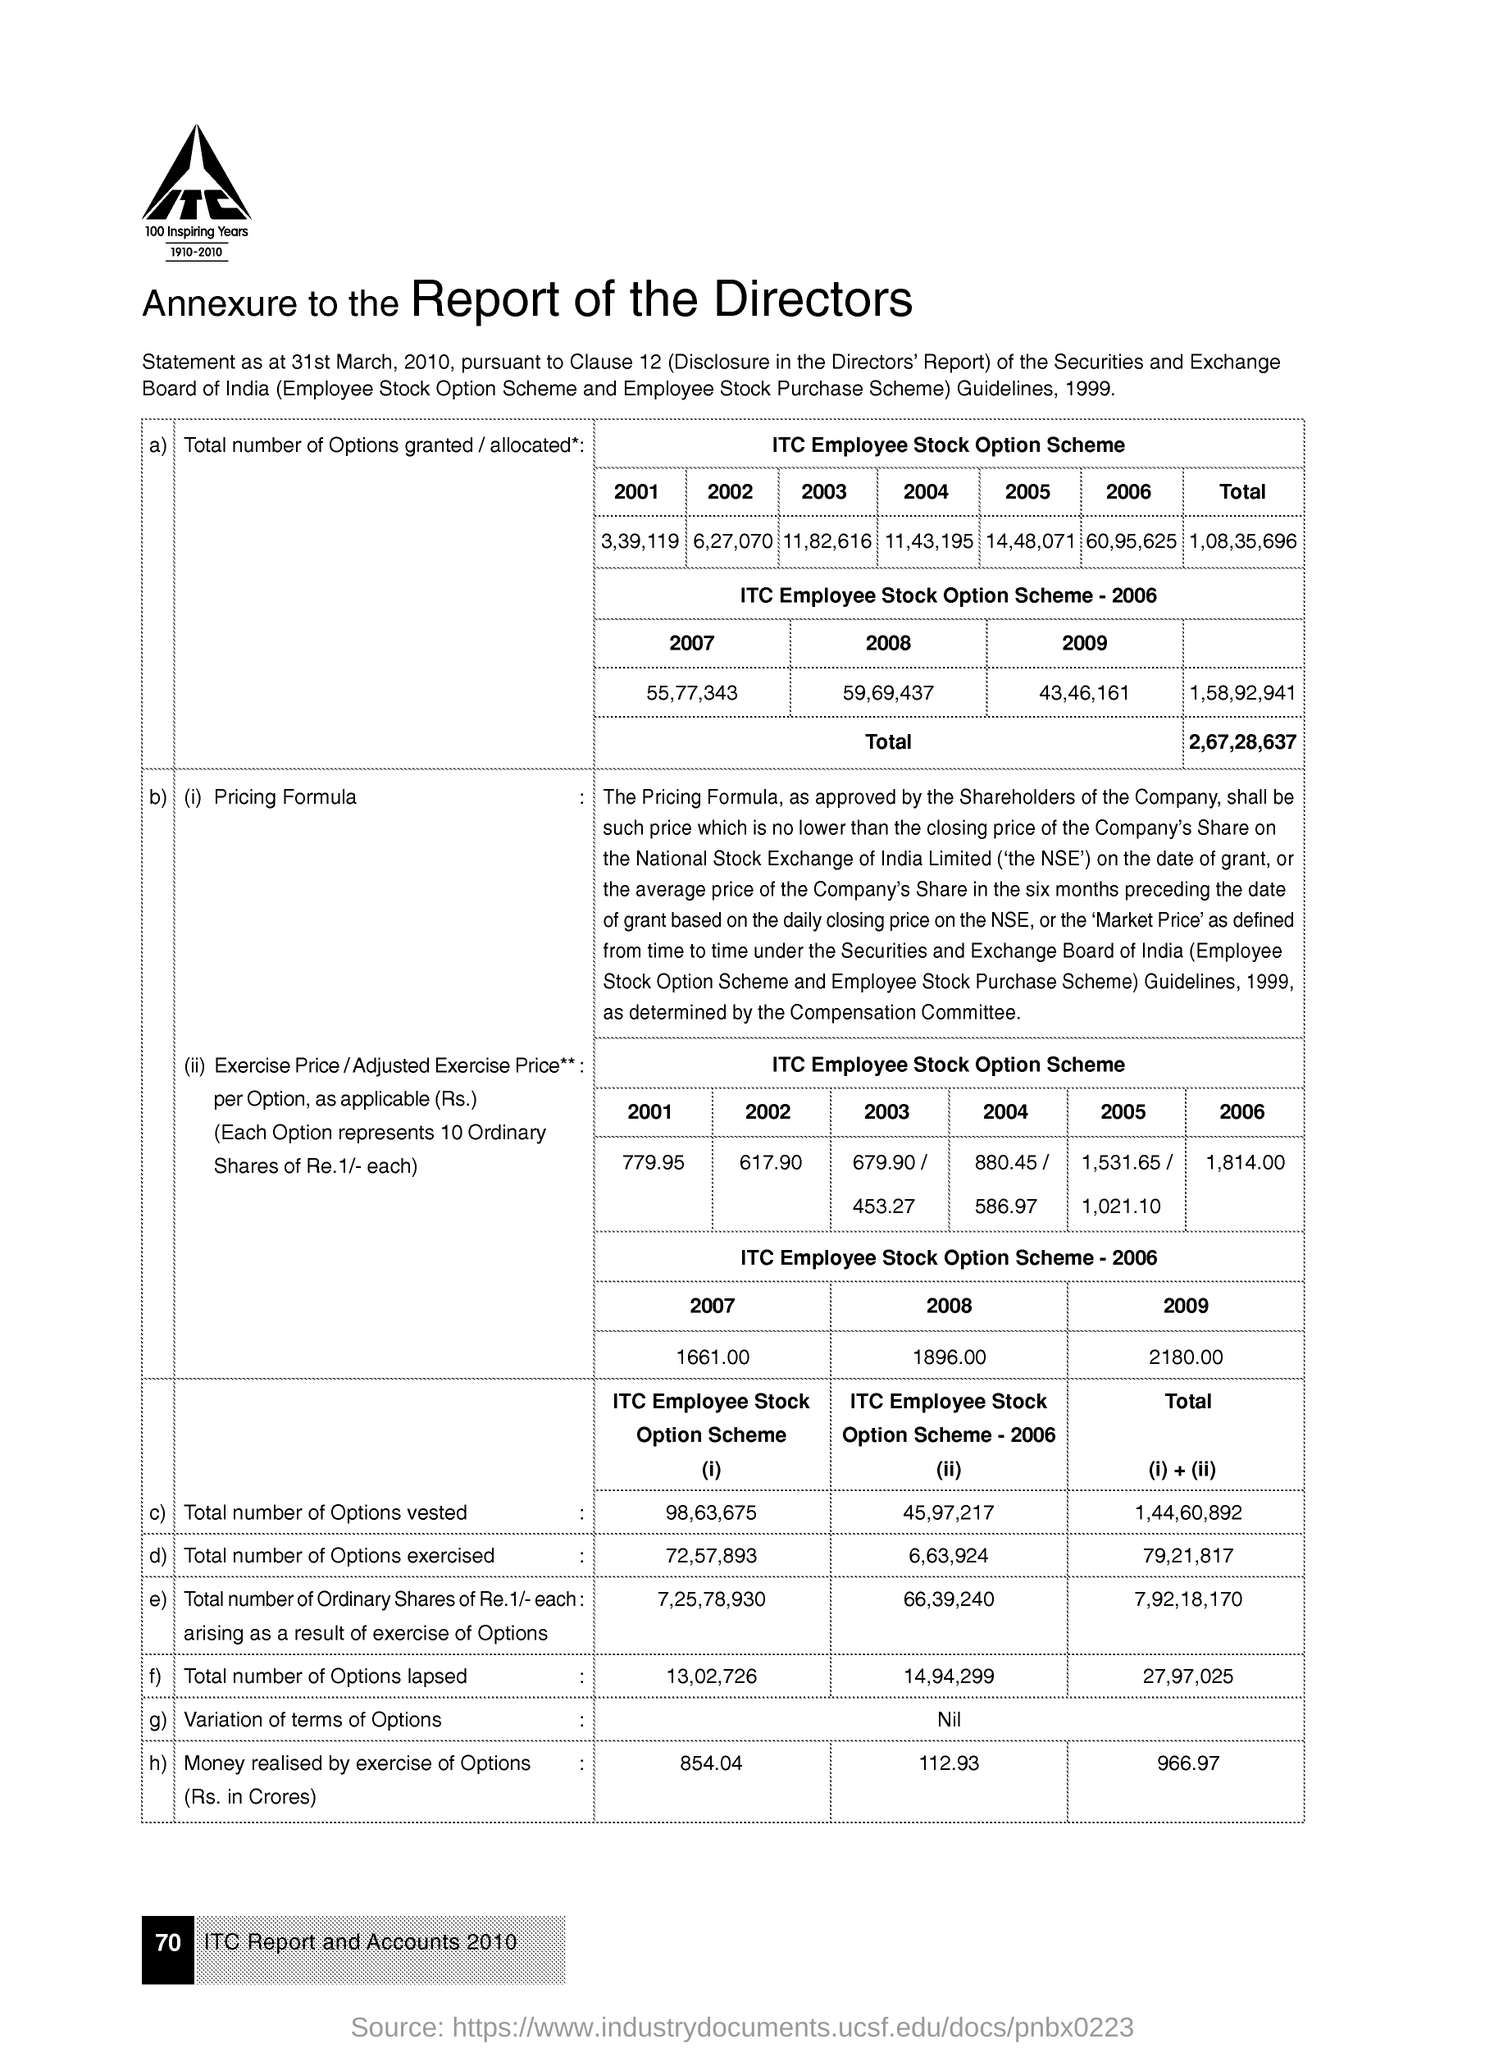Give some essential details in this illustration. In the year 2009, a total of 43,46,161 options were granted under the ITC employee stock option scheme. In the year 2004, a total of 11,43,195 options were granted under the ITC employee stock option scheme. In the year 2001, a total of 3,39,119 options were granted under the ITC employee stock option scheme. The exercise price per option under the ITC employee stock option scheme in the year 2006 was 1,814.00. In the year 2006, a total of 6,63,924 options were exercised under the ITC employees stock option scheme. 